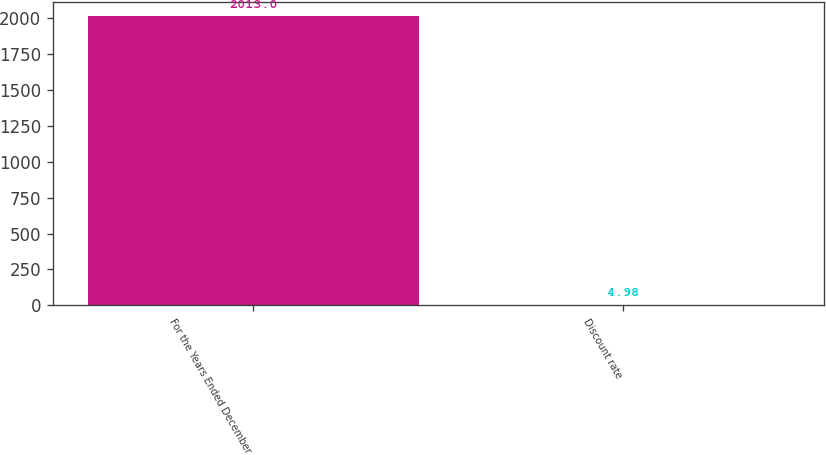Convert chart. <chart><loc_0><loc_0><loc_500><loc_500><bar_chart><fcel>For the Years Ended December<fcel>Discount rate<nl><fcel>2013<fcel>4.98<nl></chart> 